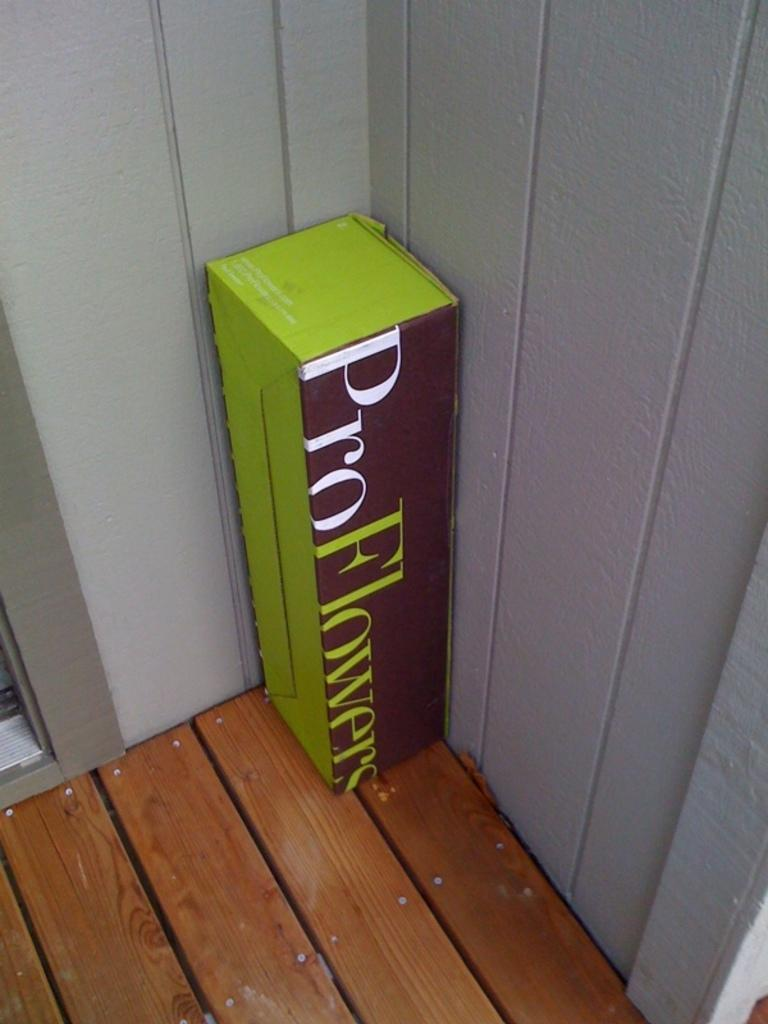<image>
Write a terse but informative summary of the picture. A box with the ProFlowers logo sits on a deck. 